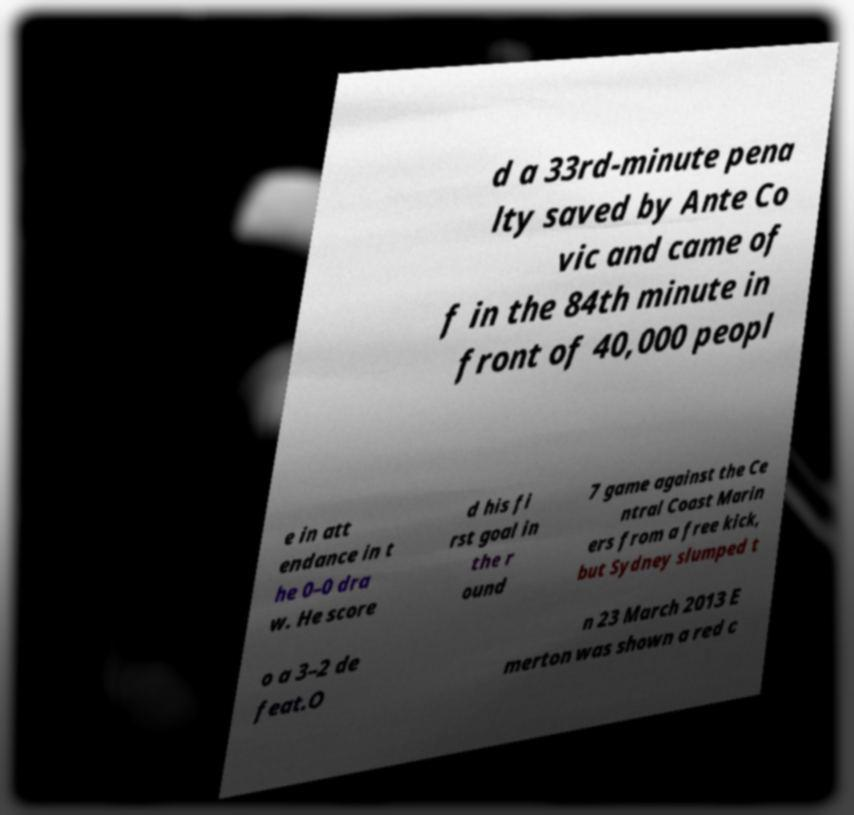Could you assist in decoding the text presented in this image and type it out clearly? d a 33rd-minute pena lty saved by Ante Co vic and came of f in the 84th minute in front of 40,000 peopl e in att endance in t he 0–0 dra w. He score d his fi rst goal in the r ound 7 game against the Ce ntral Coast Marin ers from a free kick, but Sydney slumped t o a 3–2 de feat.O n 23 March 2013 E merton was shown a red c 